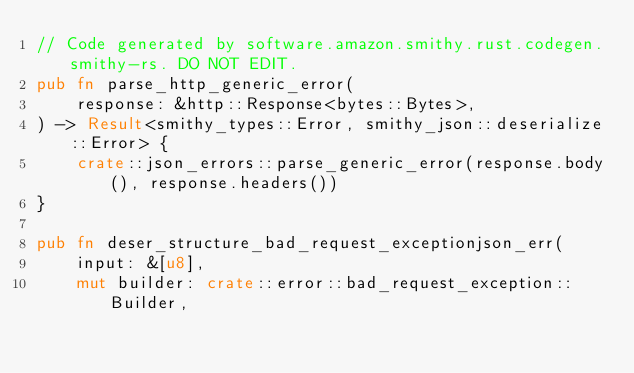Convert code to text. <code><loc_0><loc_0><loc_500><loc_500><_Rust_>// Code generated by software.amazon.smithy.rust.codegen.smithy-rs. DO NOT EDIT.
pub fn parse_http_generic_error(
    response: &http::Response<bytes::Bytes>,
) -> Result<smithy_types::Error, smithy_json::deserialize::Error> {
    crate::json_errors::parse_generic_error(response.body(), response.headers())
}

pub fn deser_structure_bad_request_exceptionjson_err(
    input: &[u8],
    mut builder: crate::error::bad_request_exception::Builder,</code> 